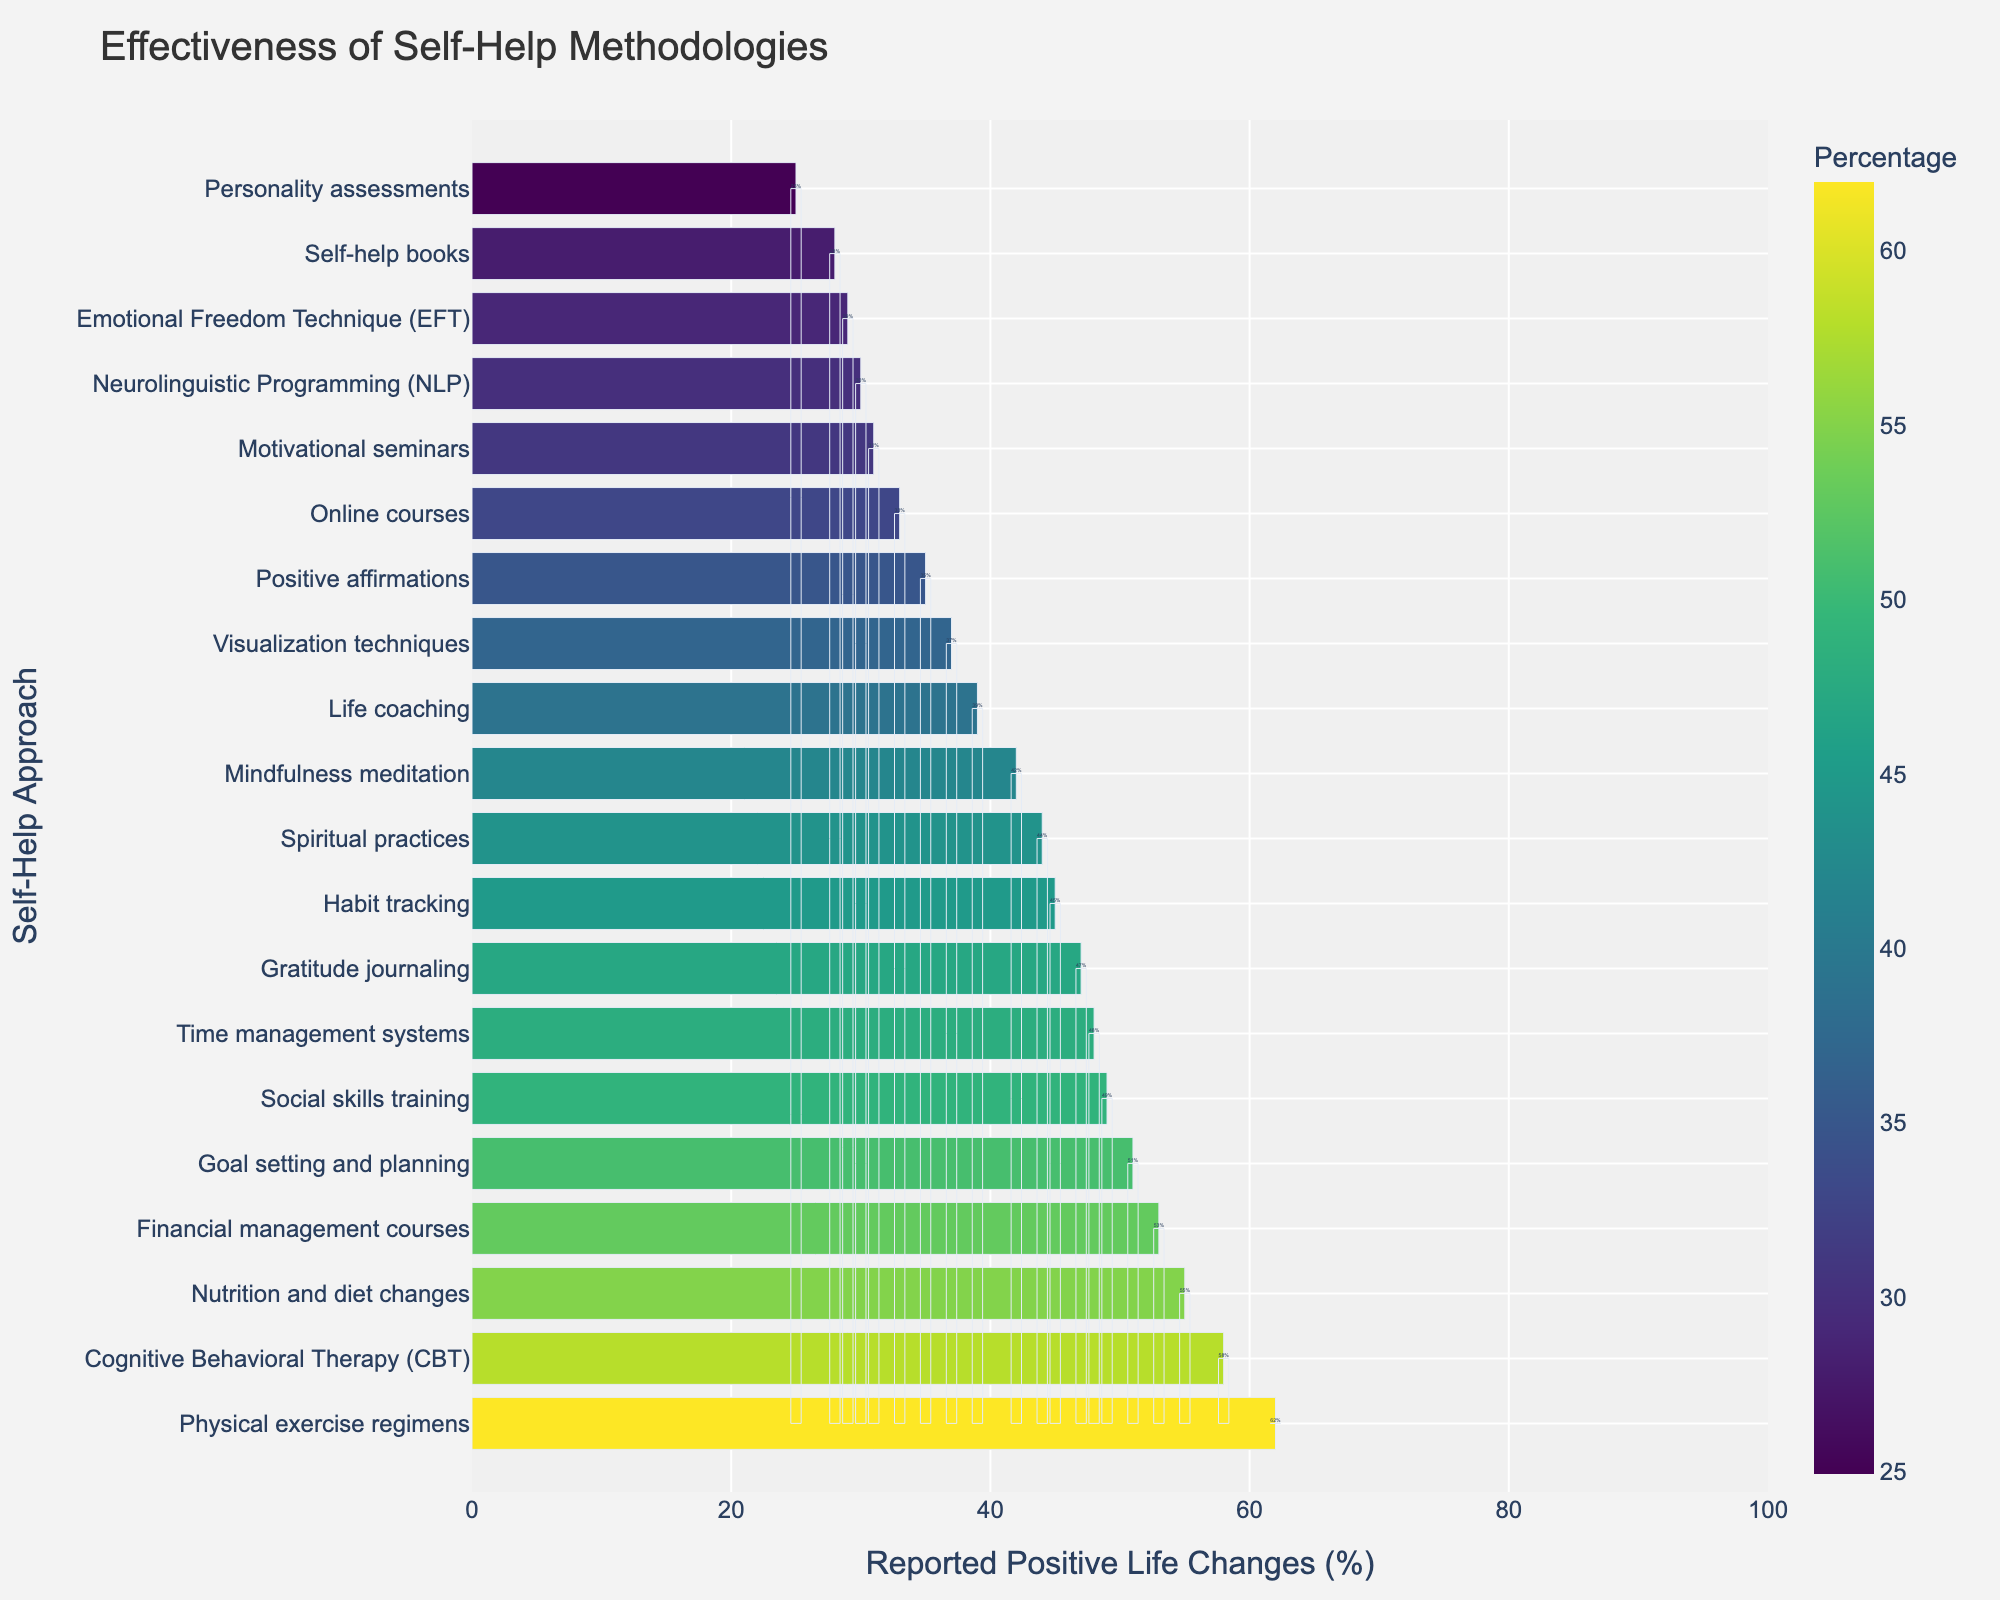What self-help approach has the highest percentage of reported positive life changes? Identify the highest bar in the chart. It corresponds to a 62% effectiveness rate, which is associated with Physical exercise regimens.
Answer: Physical exercise regimens Which self-help approaches have a reported positive life change percentage greater than 50%? Look for bars that exceed the 50% mark on the x-axis. The approaches with percentages greater than 50% are Cognitive Behavioral Therapy (58%), Nutrition and diet changes (55%), Financial management courses (53%), and Goal setting and planning (51%).
Answer: Cognitive Behavioral Therapy, Nutrition and diet changes, Financial management courses, Goal setting and planning What is the difference in the percentage of reported positive life changes between Mindfulness meditation and Life coaching? Mindfulness meditation has 42%, and Life coaching has 39%. Subtract the smaller percentage from the larger percentage: 42% - 39% = 3%.
Answer: 3% What is the median percentage of reported positive life changes across all self-help approaches? To find the median, list all percentages in ascending order and identify the middle value. The sorted list is [25, 28, 29, 30, 31, 33, 35, 37, 39, 42, 44, 45, 47, 48, 49, 51, 53, 55, 58, 62]. The median is the average of the 10th and 11th values: (42 + 44) / 2 = 43%.
Answer: 43% Which self-help approach has the second-lowest percentage of reported positive life changes? Identify the approach corresponding to the second-lowest bar in the chart. The lowest bar shows Personality assessments (25%), and the second lowest is Self-help books at 28%.
Answer: Self-help books 